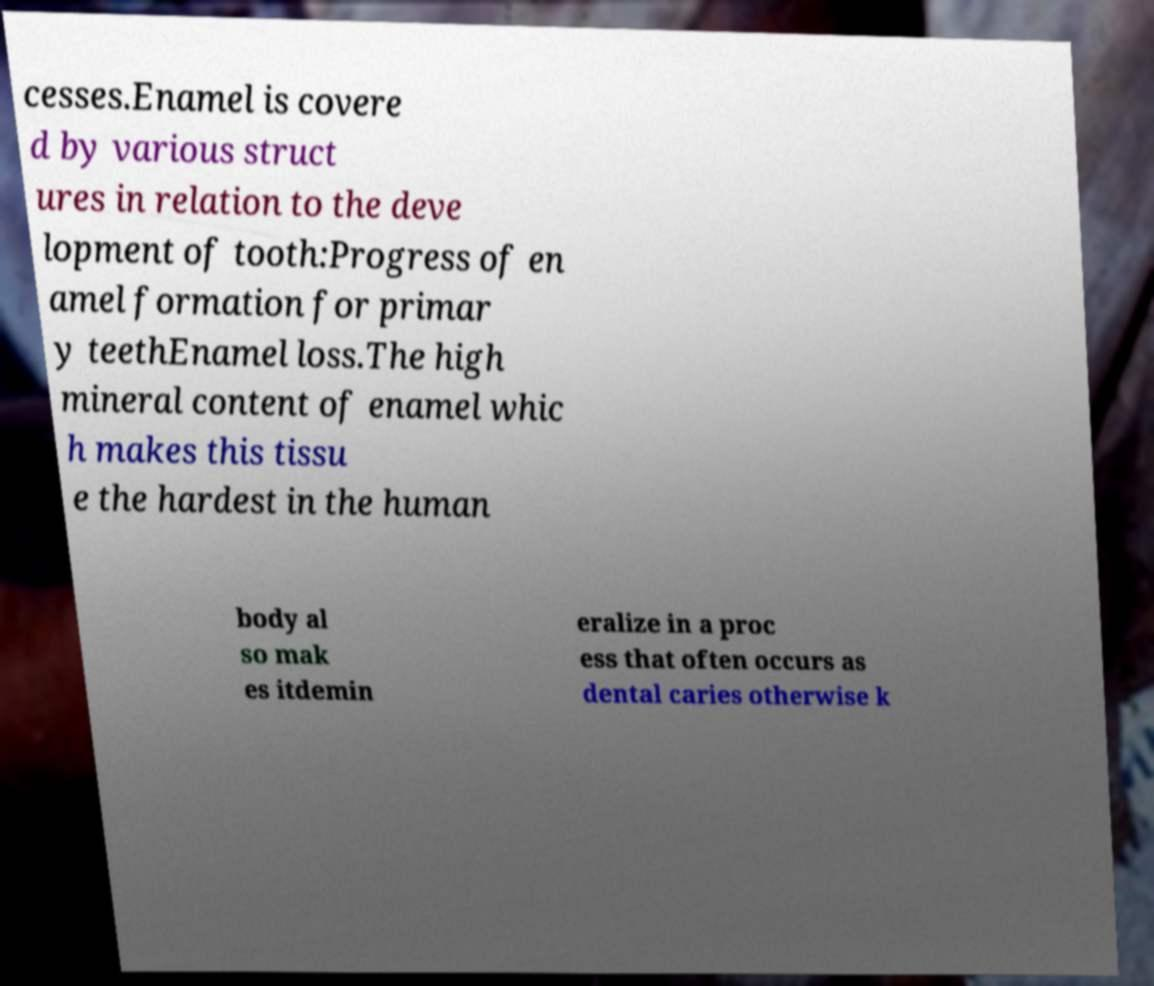Please read and relay the text visible in this image. What does it say? cesses.Enamel is covere d by various struct ures in relation to the deve lopment of tooth:Progress of en amel formation for primar y teethEnamel loss.The high mineral content of enamel whic h makes this tissu e the hardest in the human body al so mak es itdemin eralize in a proc ess that often occurs as dental caries otherwise k 